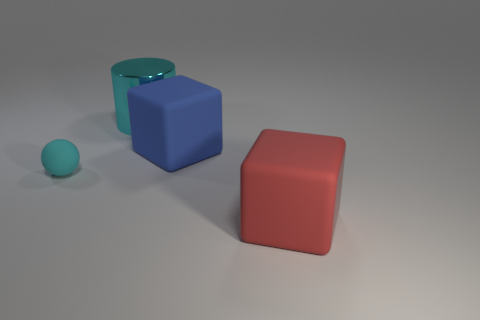What number of other things are there of the same shape as the large cyan object?
Ensure brevity in your answer.  0. What material is the small ball that is the same color as the metal thing?
Your answer should be very brief. Rubber. The big cylinder has what color?
Your answer should be very brief. Cyan. Are there any big red matte cubes behind the cyan thing that is in front of the large cylinder?
Give a very brief answer. No. What is the blue object made of?
Give a very brief answer. Rubber. Are the big block that is behind the red block and the cyan object behind the cyan sphere made of the same material?
Your answer should be compact. No. The other object that is the same shape as the large red rubber thing is what color?
Keep it short and to the point. Blue. How big is the thing that is both behind the small cyan rubber thing and in front of the metallic object?
Keep it short and to the point. Large. Does the thing that is in front of the small cyan matte object have the same shape as the rubber thing behind the cyan rubber sphere?
Your response must be concise. Yes. There is a small rubber thing that is the same color as the shiny object; what shape is it?
Your answer should be compact. Sphere. 